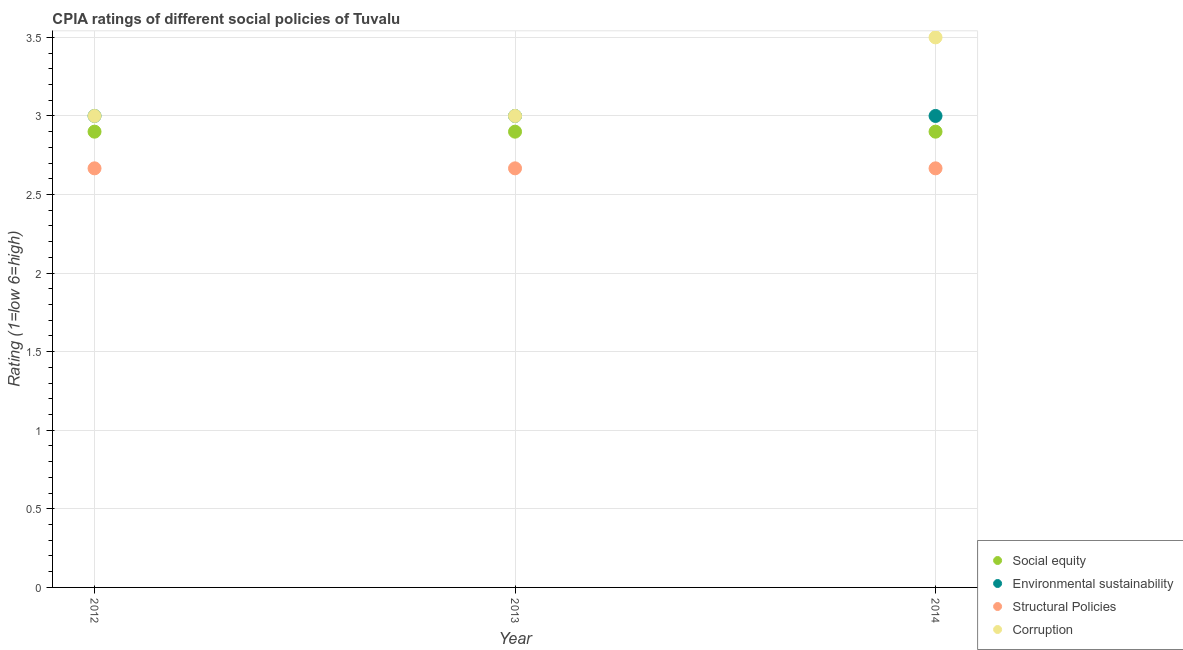Is the number of dotlines equal to the number of legend labels?
Your answer should be compact. Yes. What is the cpia rating of environmental sustainability in 2013?
Offer a very short reply. 3. Across all years, what is the maximum cpia rating of corruption?
Ensure brevity in your answer.  3.5. Across all years, what is the minimum cpia rating of corruption?
Your response must be concise. 3. In which year was the cpia rating of structural policies maximum?
Provide a short and direct response. 2014. What is the total cpia rating of corruption in the graph?
Offer a very short reply. 9.5. What is the difference between the cpia rating of corruption in 2012 and that in 2014?
Offer a very short reply. -0.5. What is the difference between the cpia rating of structural policies in 2014 and the cpia rating of social equity in 2013?
Your answer should be very brief. -0.23. In how many years, is the cpia rating of environmental sustainability greater than 1.1?
Make the answer very short. 3. What is the ratio of the cpia rating of corruption in 2013 to that in 2014?
Your answer should be very brief. 0.86. Is the cpia rating of environmental sustainability in 2012 less than that in 2013?
Your answer should be compact. No. Is the sum of the cpia rating of structural policies in 2013 and 2014 greater than the maximum cpia rating of environmental sustainability across all years?
Make the answer very short. Yes. How many dotlines are there?
Offer a very short reply. 4. How many years are there in the graph?
Offer a very short reply. 3. What is the difference between two consecutive major ticks on the Y-axis?
Keep it short and to the point. 0.5. Are the values on the major ticks of Y-axis written in scientific E-notation?
Provide a succinct answer. No. Does the graph contain any zero values?
Your answer should be very brief. No. Does the graph contain grids?
Offer a very short reply. Yes. How are the legend labels stacked?
Ensure brevity in your answer.  Vertical. What is the title of the graph?
Offer a very short reply. CPIA ratings of different social policies of Tuvalu. Does "Negligence towards children" appear as one of the legend labels in the graph?
Your answer should be very brief. No. What is the label or title of the X-axis?
Offer a very short reply. Year. What is the Rating (1=low 6=high) in Environmental sustainability in 2012?
Provide a short and direct response. 3. What is the Rating (1=low 6=high) of Structural Policies in 2012?
Keep it short and to the point. 2.67. What is the Rating (1=low 6=high) in Environmental sustainability in 2013?
Provide a short and direct response. 3. What is the Rating (1=low 6=high) of Structural Policies in 2013?
Keep it short and to the point. 2.67. What is the Rating (1=low 6=high) of Social equity in 2014?
Your response must be concise. 2.9. What is the Rating (1=low 6=high) in Environmental sustainability in 2014?
Offer a terse response. 3. What is the Rating (1=low 6=high) in Structural Policies in 2014?
Your answer should be compact. 2.67. Across all years, what is the maximum Rating (1=low 6=high) in Environmental sustainability?
Offer a terse response. 3. Across all years, what is the maximum Rating (1=low 6=high) of Structural Policies?
Ensure brevity in your answer.  2.67. Across all years, what is the minimum Rating (1=low 6=high) in Social equity?
Ensure brevity in your answer.  2.9. Across all years, what is the minimum Rating (1=low 6=high) of Environmental sustainability?
Provide a succinct answer. 3. Across all years, what is the minimum Rating (1=low 6=high) of Structural Policies?
Provide a short and direct response. 2.67. What is the total Rating (1=low 6=high) in Environmental sustainability in the graph?
Offer a very short reply. 9. What is the total Rating (1=low 6=high) of Structural Policies in the graph?
Your answer should be compact. 8. What is the difference between the Rating (1=low 6=high) in Social equity in 2012 and that in 2013?
Your response must be concise. 0. What is the difference between the Rating (1=low 6=high) of Corruption in 2012 and that in 2013?
Your answer should be compact. 0. What is the difference between the Rating (1=low 6=high) of Social equity in 2012 and that in 2014?
Offer a terse response. 0. What is the difference between the Rating (1=low 6=high) of Environmental sustainability in 2012 and that in 2014?
Provide a succinct answer. 0. What is the difference between the Rating (1=low 6=high) of Structural Policies in 2012 and that in 2014?
Ensure brevity in your answer.  -0. What is the difference between the Rating (1=low 6=high) in Corruption in 2013 and that in 2014?
Your answer should be very brief. -0.5. What is the difference between the Rating (1=low 6=high) of Social equity in 2012 and the Rating (1=low 6=high) of Structural Policies in 2013?
Give a very brief answer. 0.23. What is the difference between the Rating (1=low 6=high) of Structural Policies in 2012 and the Rating (1=low 6=high) of Corruption in 2013?
Your response must be concise. -0.33. What is the difference between the Rating (1=low 6=high) of Social equity in 2012 and the Rating (1=low 6=high) of Environmental sustainability in 2014?
Ensure brevity in your answer.  -0.1. What is the difference between the Rating (1=low 6=high) of Social equity in 2012 and the Rating (1=low 6=high) of Structural Policies in 2014?
Your answer should be compact. 0.23. What is the difference between the Rating (1=low 6=high) in Environmental sustainability in 2012 and the Rating (1=low 6=high) in Corruption in 2014?
Provide a succinct answer. -0.5. What is the difference between the Rating (1=low 6=high) of Structural Policies in 2012 and the Rating (1=low 6=high) of Corruption in 2014?
Offer a terse response. -0.83. What is the difference between the Rating (1=low 6=high) in Social equity in 2013 and the Rating (1=low 6=high) in Environmental sustainability in 2014?
Offer a terse response. -0.1. What is the difference between the Rating (1=low 6=high) in Social equity in 2013 and the Rating (1=low 6=high) in Structural Policies in 2014?
Keep it short and to the point. 0.23. What is the difference between the Rating (1=low 6=high) in Environmental sustainability in 2013 and the Rating (1=low 6=high) in Structural Policies in 2014?
Keep it short and to the point. 0.33. What is the difference between the Rating (1=low 6=high) in Environmental sustainability in 2013 and the Rating (1=low 6=high) in Corruption in 2014?
Give a very brief answer. -0.5. What is the average Rating (1=low 6=high) of Social equity per year?
Your response must be concise. 2.9. What is the average Rating (1=low 6=high) in Environmental sustainability per year?
Your response must be concise. 3. What is the average Rating (1=low 6=high) in Structural Policies per year?
Make the answer very short. 2.67. What is the average Rating (1=low 6=high) in Corruption per year?
Offer a very short reply. 3.17. In the year 2012, what is the difference between the Rating (1=low 6=high) of Social equity and Rating (1=low 6=high) of Environmental sustainability?
Keep it short and to the point. -0.1. In the year 2012, what is the difference between the Rating (1=low 6=high) of Social equity and Rating (1=low 6=high) of Structural Policies?
Keep it short and to the point. 0.23. In the year 2012, what is the difference between the Rating (1=low 6=high) in Structural Policies and Rating (1=low 6=high) in Corruption?
Your response must be concise. -0.33. In the year 2013, what is the difference between the Rating (1=low 6=high) in Social equity and Rating (1=low 6=high) in Structural Policies?
Make the answer very short. 0.23. In the year 2013, what is the difference between the Rating (1=low 6=high) of Social equity and Rating (1=low 6=high) of Corruption?
Offer a very short reply. -0.1. In the year 2013, what is the difference between the Rating (1=low 6=high) of Environmental sustainability and Rating (1=low 6=high) of Structural Policies?
Your answer should be very brief. 0.33. In the year 2013, what is the difference between the Rating (1=low 6=high) in Environmental sustainability and Rating (1=low 6=high) in Corruption?
Offer a terse response. 0. In the year 2013, what is the difference between the Rating (1=low 6=high) of Structural Policies and Rating (1=low 6=high) of Corruption?
Ensure brevity in your answer.  -0.33. In the year 2014, what is the difference between the Rating (1=low 6=high) in Social equity and Rating (1=low 6=high) in Structural Policies?
Keep it short and to the point. 0.23. In the year 2014, what is the difference between the Rating (1=low 6=high) in Social equity and Rating (1=low 6=high) in Corruption?
Keep it short and to the point. -0.6. In the year 2014, what is the difference between the Rating (1=low 6=high) in Environmental sustainability and Rating (1=low 6=high) in Corruption?
Offer a very short reply. -0.5. In the year 2014, what is the difference between the Rating (1=low 6=high) in Structural Policies and Rating (1=low 6=high) in Corruption?
Keep it short and to the point. -0.83. What is the ratio of the Rating (1=low 6=high) of Environmental sustainability in 2012 to that in 2013?
Provide a short and direct response. 1. What is the ratio of the Rating (1=low 6=high) in Corruption in 2012 to that in 2013?
Make the answer very short. 1. What is the ratio of the Rating (1=low 6=high) of Structural Policies in 2012 to that in 2014?
Provide a succinct answer. 1. What is the ratio of the Rating (1=low 6=high) of Social equity in 2013 to that in 2014?
Provide a succinct answer. 1. What is the ratio of the Rating (1=low 6=high) of Environmental sustainability in 2013 to that in 2014?
Your answer should be very brief. 1. What is the ratio of the Rating (1=low 6=high) in Structural Policies in 2013 to that in 2014?
Provide a short and direct response. 1. What is the difference between the highest and the second highest Rating (1=low 6=high) of Social equity?
Your answer should be very brief. 0. What is the difference between the highest and the second highest Rating (1=low 6=high) in Environmental sustainability?
Offer a terse response. 0. What is the difference between the highest and the lowest Rating (1=low 6=high) in Social equity?
Provide a short and direct response. 0. What is the difference between the highest and the lowest Rating (1=low 6=high) in Environmental sustainability?
Your answer should be very brief. 0. 